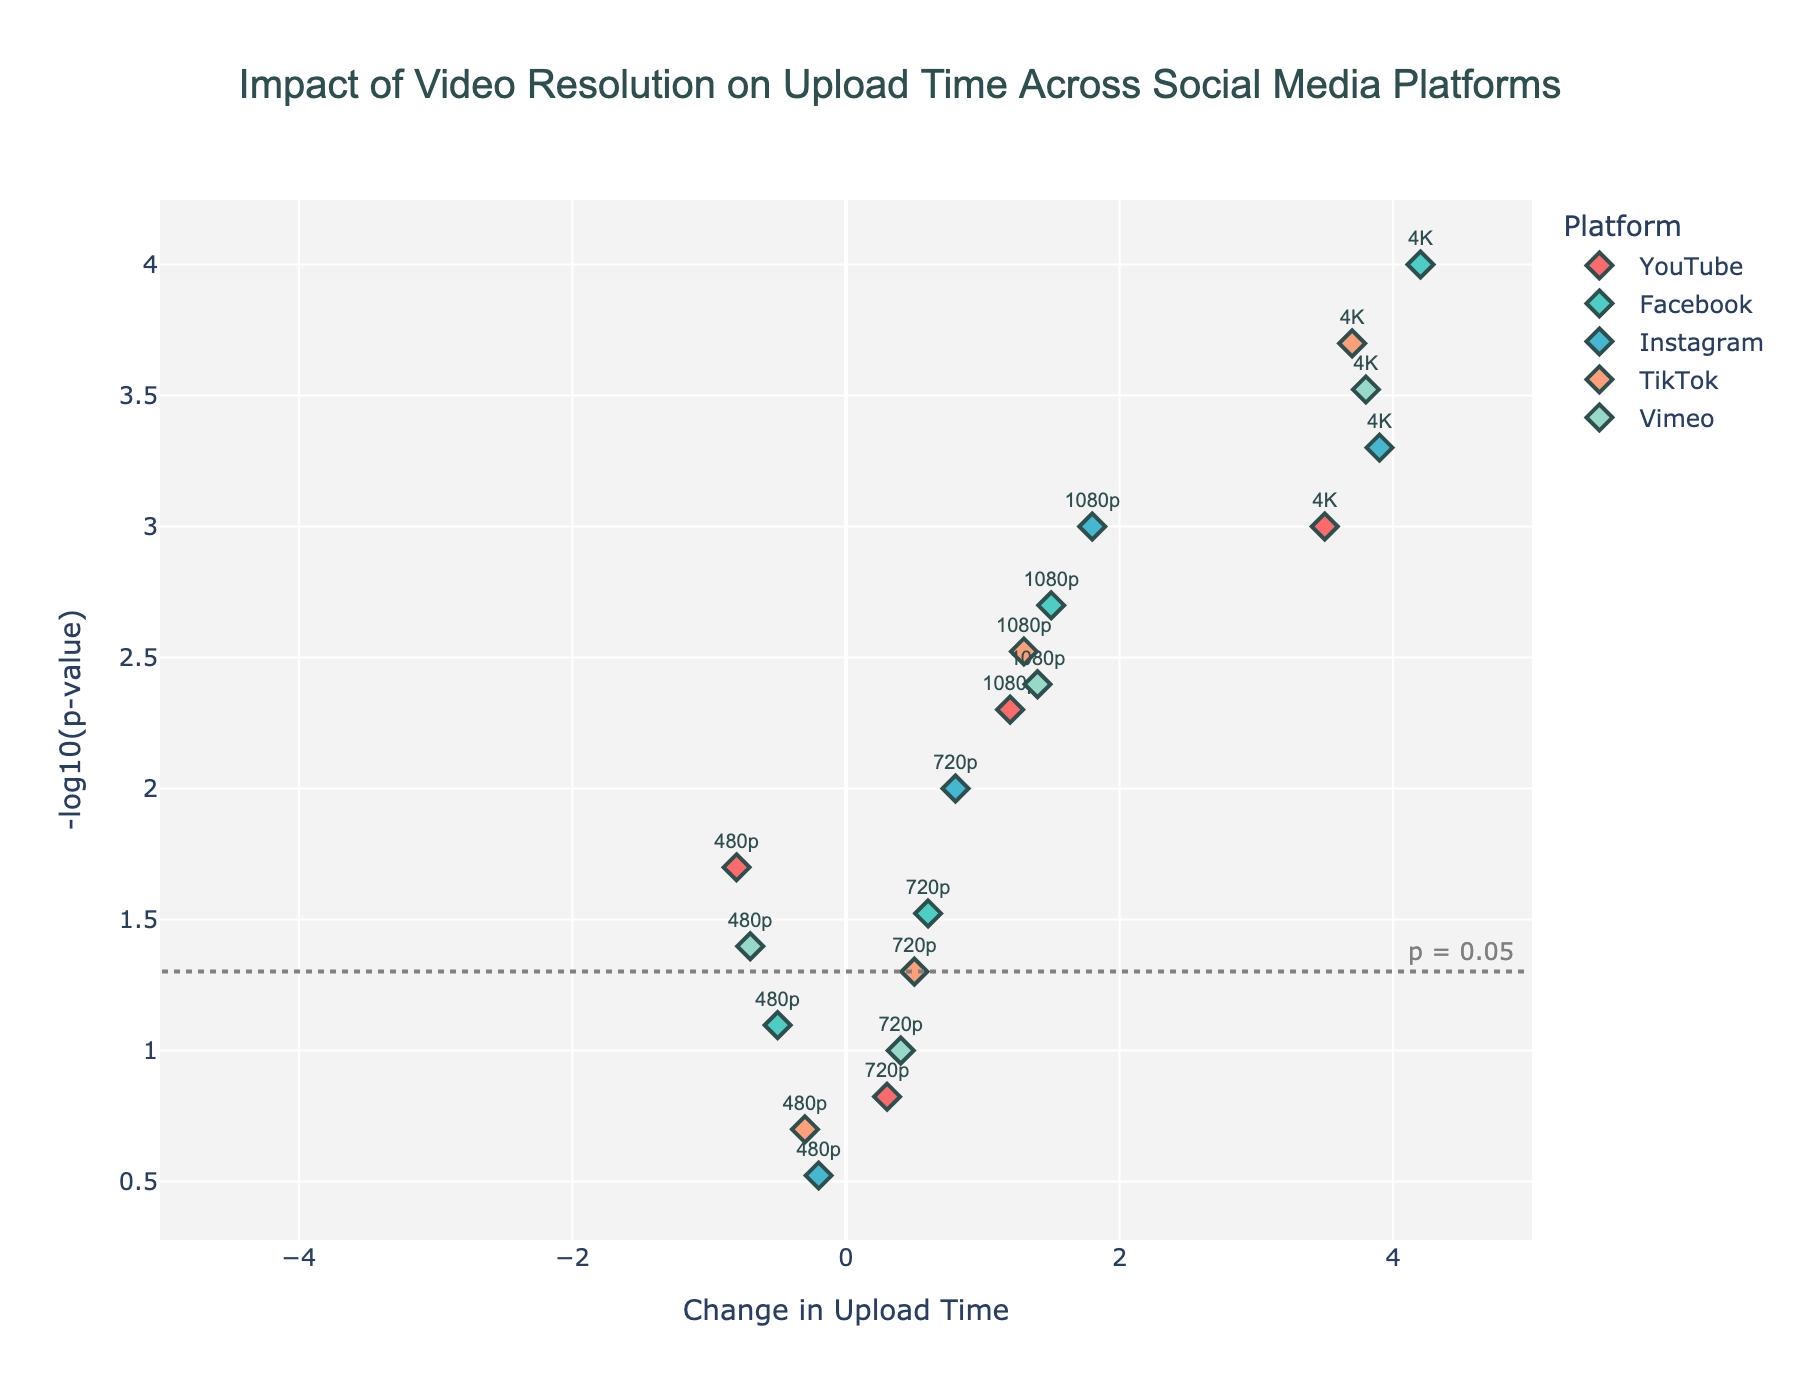What is the highest change in upload time indicated on the plot? To find the highest change, look for the data point with the maximum x-axis value (Upload Time Change). This value represents the largest variation in upload time. The highest x-axis value is 4.2, which belongs to 4K on Facebook.
Answer: 4.2 Which platform has the smallest change in upload time at 720p resolution? Identify the 720p data points on the plot, which labels the resolutions. Observe the x-axis positions for these 720p data points across platforms. TikTok at 720p has the smallest change in upload time, with a value of 0.5.
Answer: TikTok What resolution on YouTube has the highest significance level of upload time change? Look for the YouTube data points. Compare their y-axis values (-log10(p-value)). Higher y-axis value means higher significance. The 4K resolution on YouTube has the highest y-axis value (~3), indicating it has the highest significance level.
Answer: 4K How does the upload time change at 1080p on Instagram compare to that of 4K on TikTok? Locate the 1080p point for Instagram and the 4K point for TikTok. Compare their x-axis values (Upload Time Change). 1080p on Instagram has an upload time change of 1.8, while 4K on TikTok has 3.7. 1080p on Instagram has a lower change than 4K on TikTok.
Answer: 1080p on Instagram is lower What is the significance threshold level marked on the plot? Find the horizontal line labeled 'p = 0.05'. This line indicates the significance threshold where the y-axis value is -log10(0.05). The approximate value on the y-axis is 1.3.
Answer: 1.3 How many platforms show a decreased upload time at 480p resolution? Identify the 480p resolution points and check x-axis values for negativity (decreased upload time). The platforms showing negative upload time at 480p are YouTube, Facebook, Instagram, TikTok, and Vimeo - a total of 5 platforms.
Answer: 5 platforms What is the upload time change for 1080p resolution on Vimeo, and is it significant? Find the 1080p point for Vimeo on the plot. The x-axis value is 1.4. Check if the y-value is above the significance threshold (1.3). Vimeo's 1080p y-axis value (~2.4) is above 1.3, making it significant.
Answer: 1.4, significant Which platform has the most consistent (least variable) upload time changes across all resolutions? Assess all platforms for their data points spread along the x-axis (Upload Time Change). Vimeo’s points are relatively close along the x-axis, indicating consistency.
Answer: Vimeo For 4K resolution, which platform has the most significant change in upload time? Compare the 4K resolution points for the highest y-axis value (significance). Facebook's 4K point has the highest y-value (~4), hence, the most significant.
Answer: Facebook What’s the log-transformed significance level for the 720p resolution on Instagram? Locate the 720p resolution point for Instagram and read its y-axis value, which represents the -log10(p-value). The value is around 2.
Answer: Around 2 